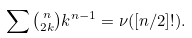<formula> <loc_0><loc_0><loc_500><loc_500>\sum \tbinom n { 2 k } k ^ { n - 1 } = \nu ( [ n / 2 ] ! ) .</formula> 